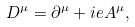Convert formula to latex. <formula><loc_0><loc_0><loc_500><loc_500>D ^ { \mu } = \partial ^ { \mu } + i e A ^ { \mu } ,</formula> 